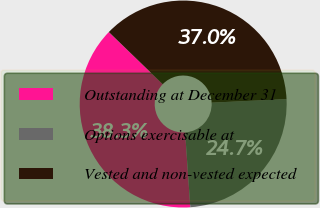Convert chart to OTSL. <chart><loc_0><loc_0><loc_500><loc_500><pie_chart><fcel>Outstanding at December 31<fcel>Options exercisable at<fcel>Vested and non-vested expected<nl><fcel>38.34%<fcel>24.66%<fcel>37.0%<nl></chart> 